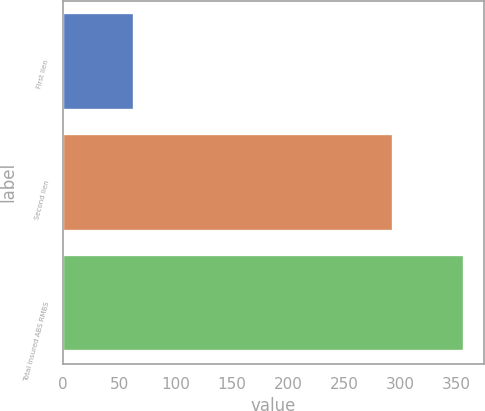Convert chart. <chart><loc_0><loc_0><loc_500><loc_500><bar_chart><fcel>First lien<fcel>Second lien<fcel>Total insured ABS RMBS<nl><fcel>63<fcel>293<fcel>356<nl></chart> 